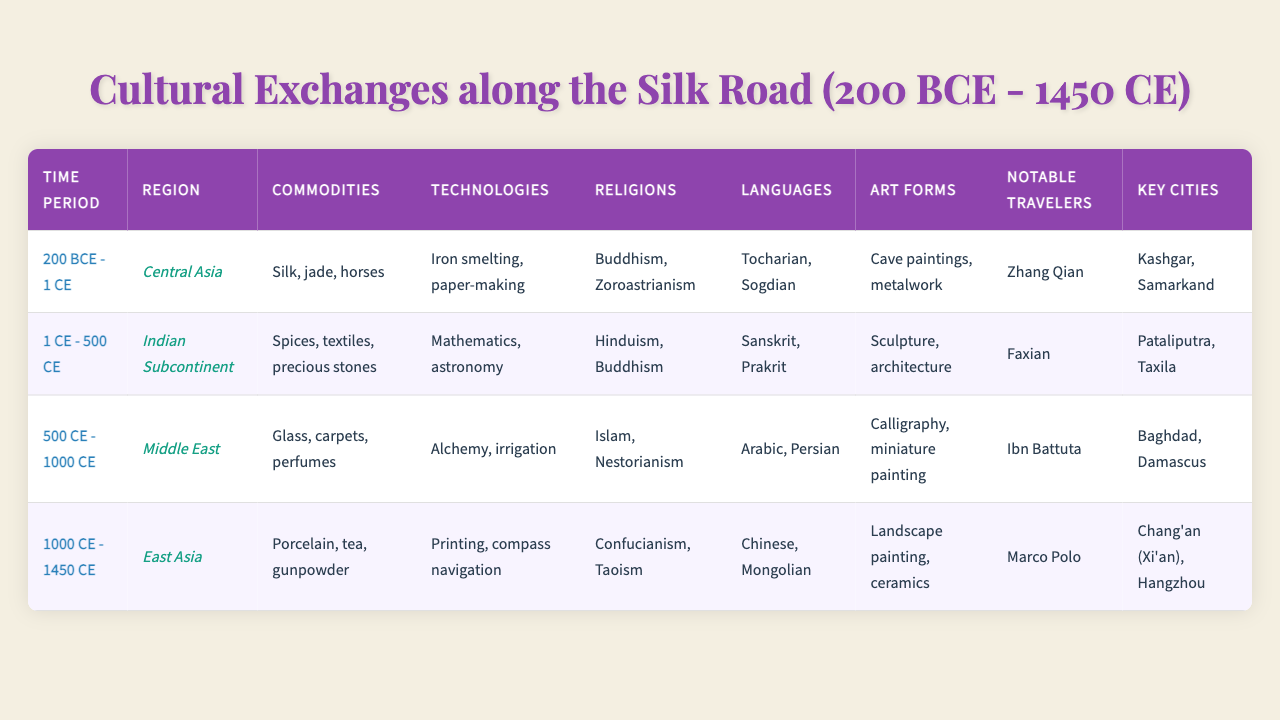What commodities were traded in Central Asia between 200 BCE and 1 CE? According to the table, the commodities traded in Central Asia during this time period included silk, jade, and horses.
Answer: Silk, jade, horses Who was a notable traveler in the Indian Subcontinent from 1 CE to 500 CE? The table lists Faxian as the notable traveler during this time period in the Indian Subcontinent.
Answer: Faxian What technologies were developed in the Middle East from 500 CE to 1000 CE? The table indicates that alchemy and irrigation were among the technologies developed in the Middle East during this time period.
Answer: Alchemy, irrigation Which religions were prominent in East Asia between 1000 CE and 1450 CE? Confucianism and Taoism were the prominent religions noted for East Asia in this timeframe according to the table.
Answer: Confucianism, Taoism In which region were glass and carpets traded between 500 CE and 1000 CE? The Middle East is identified as the region where glass and carpets were traded during this period in the table.
Answer: Middle East What is the average number of languages listed for each region in the table? The regions have the following languages: Central Asia (2), Indian Subcontinent (2), Middle East (2), and East Asia (2). Total = 8 languages across 4 regions, average = 8/4 = 2.
Answer: 2 Did the technologies of printing and compass navigation develop in the Indian Subcontinent during 1 CE to 500 CE? The table indicates that the technologies for this period were mathematics and astronomy, not printing and compass navigation. Thus, the statement is false.
Answer: False Which region had the most notable traveler and which one was it, according to the table? The East Asia region had Marco Polo as its notable traveler, while other regions also had notable travelers, but Marco Polo is particularly famous.
Answer: East Asia, Marco Polo List all art forms present in the Middle East during 500 CE to 1000 CE. The table identifies calligraphy and miniature painting as the art forms present in the Middle East during this period.
Answer: Calligraphy, miniature painting Was Pataliputra a key city in East Asia? According to the table, Pataliputra is listed as a key city in the Indian Subcontinent, not East Asia, so the statement is false.
Answer: False 